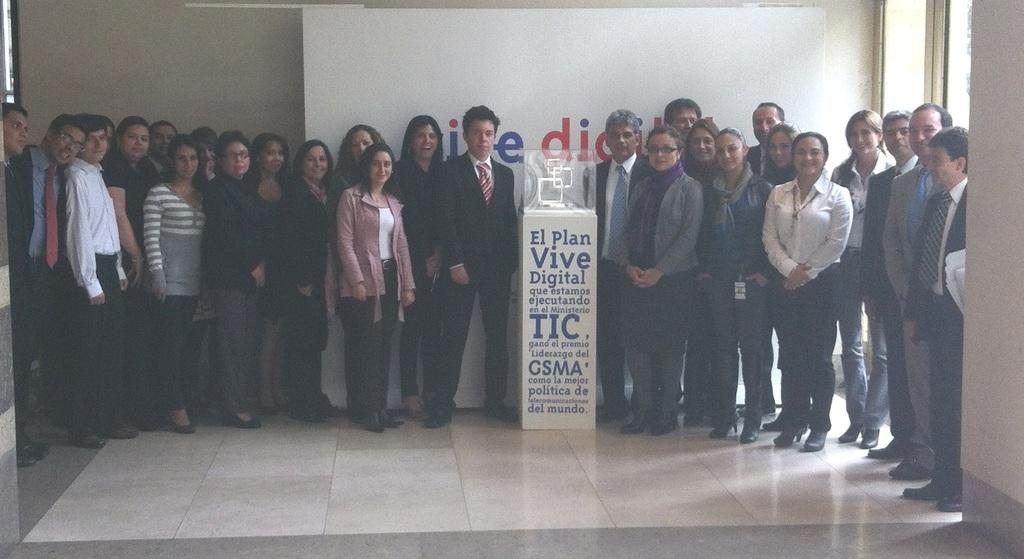What is happening in the image? There are people standing in the image. Can you describe any objects in the image? There is a white color object in the image. What can be seen in the background of the image? There is a wall in the background of the image. How many people are attacking the white object in the image? There is no attack or white object being attacked in the image; it only shows people standing and a wall in the background. 